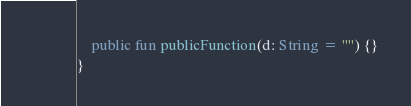<code> <loc_0><loc_0><loc_500><loc_500><_Kotlin_>    public fun publicFunction(d: String = "") {}
}
</code> 